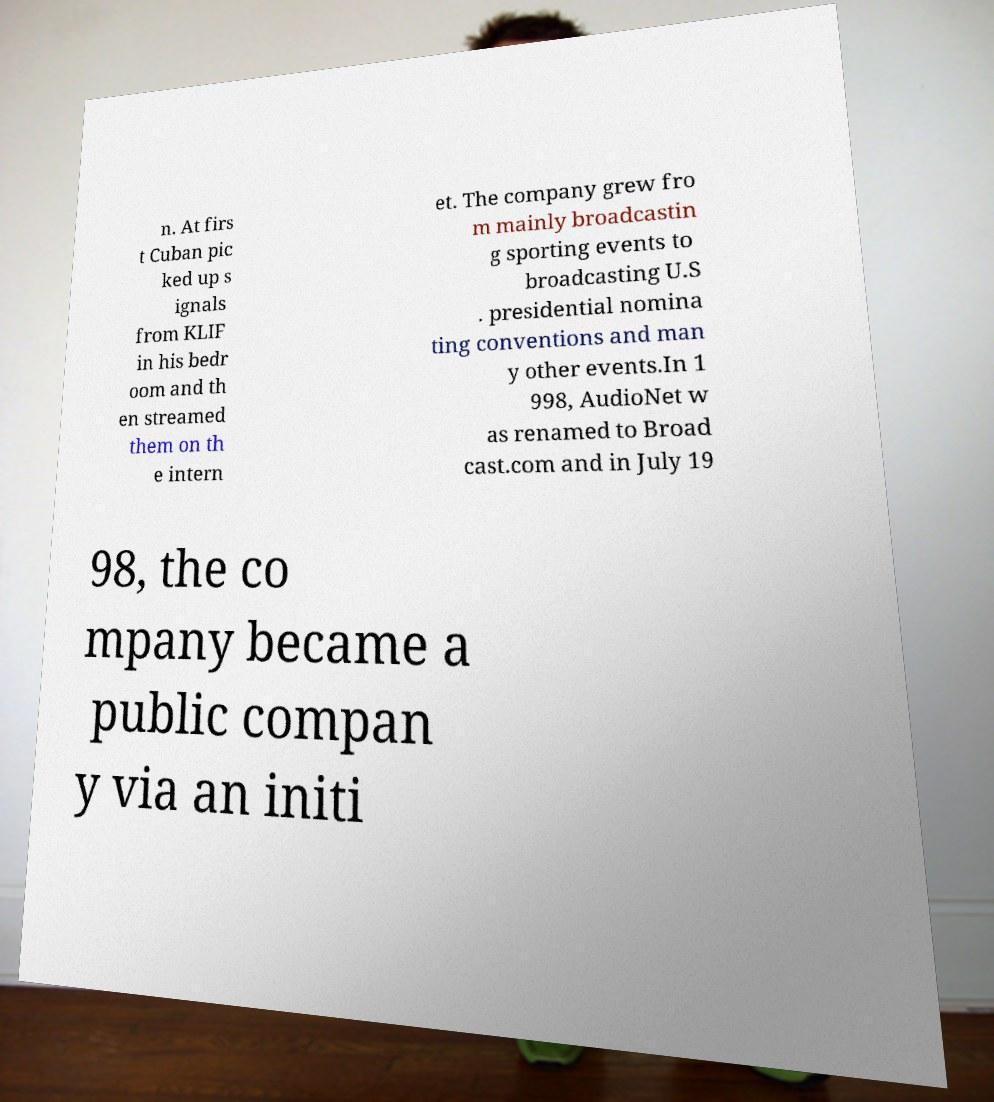Could you assist in decoding the text presented in this image and type it out clearly? n. At firs t Cuban pic ked up s ignals from KLIF in his bedr oom and th en streamed them on th e intern et. The company grew fro m mainly broadcastin g sporting events to broadcasting U.S . presidential nomina ting conventions and man y other events.In 1 998, AudioNet w as renamed to Broad cast.com and in July 19 98, the co mpany became a public compan y via an initi 